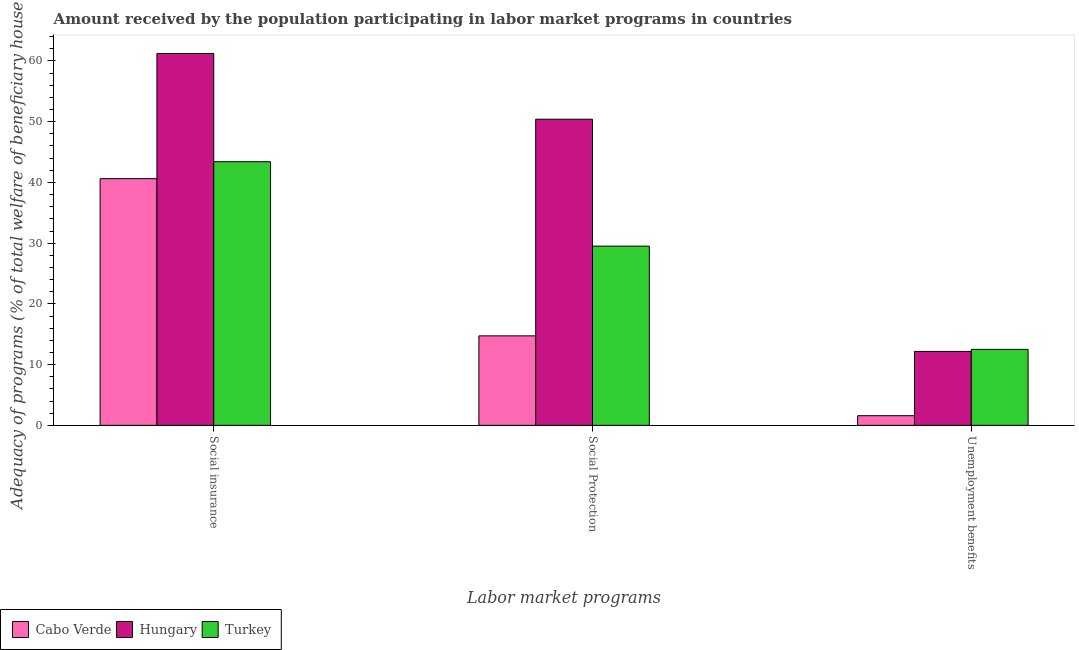Are the number of bars on each tick of the X-axis equal?
Provide a succinct answer. Yes. What is the label of the 2nd group of bars from the left?
Your response must be concise. Social Protection. What is the amount received by the population participating in social protection programs in Turkey?
Your response must be concise. 29.51. Across all countries, what is the maximum amount received by the population participating in unemployment benefits programs?
Your response must be concise. 12.51. Across all countries, what is the minimum amount received by the population participating in unemployment benefits programs?
Ensure brevity in your answer.  1.59. In which country was the amount received by the population participating in social protection programs maximum?
Provide a short and direct response. Hungary. In which country was the amount received by the population participating in unemployment benefits programs minimum?
Offer a very short reply. Cabo Verde. What is the total amount received by the population participating in social insurance programs in the graph?
Make the answer very short. 145.27. What is the difference between the amount received by the population participating in social insurance programs in Turkey and that in Cabo Verde?
Make the answer very short. 2.79. What is the difference between the amount received by the population participating in social protection programs in Hungary and the amount received by the population participating in unemployment benefits programs in Turkey?
Give a very brief answer. 37.9. What is the average amount received by the population participating in social protection programs per country?
Provide a succinct answer. 31.55. What is the difference between the amount received by the population participating in social insurance programs and amount received by the population participating in unemployment benefits programs in Hungary?
Make the answer very short. 49.06. In how many countries, is the amount received by the population participating in social protection programs greater than 36 %?
Provide a succinct answer. 1. What is the ratio of the amount received by the population participating in unemployment benefits programs in Turkey to that in Hungary?
Your response must be concise. 1.03. Is the amount received by the population participating in social insurance programs in Cabo Verde less than that in Turkey?
Your answer should be very brief. Yes. What is the difference between the highest and the second highest amount received by the population participating in unemployment benefits programs?
Provide a succinct answer. 0.34. What is the difference between the highest and the lowest amount received by the population participating in social insurance programs?
Offer a terse response. 20.62. What does the 1st bar from the left in Social Protection represents?
Provide a short and direct response. Cabo Verde. What does the 3rd bar from the right in Social Protection represents?
Ensure brevity in your answer.  Cabo Verde. Is it the case that in every country, the sum of the amount received by the population participating in social insurance programs and amount received by the population participating in social protection programs is greater than the amount received by the population participating in unemployment benefits programs?
Keep it short and to the point. Yes. Are all the bars in the graph horizontal?
Your answer should be compact. No. Does the graph contain grids?
Provide a short and direct response. No. Where does the legend appear in the graph?
Your answer should be very brief. Bottom left. How are the legend labels stacked?
Ensure brevity in your answer.  Horizontal. What is the title of the graph?
Ensure brevity in your answer.  Amount received by the population participating in labor market programs in countries. Does "Benin" appear as one of the legend labels in the graph?
Your response must be concise. No. What is the label or title of the X-axis?
Offer a terse response. Labor market programs. What is the label or title of the Y-axis?
Offer a terse response. Adequacy of programs (% of total welfare of beneficiary households). What is the Adequacy of programs (% of total welfare of beneficiary households) in Cabo Verde in Social insurance?
Your answer should be compact. 40.62. What is the Adequacy of programs (% of total welfare of beneficiary households) of Hungary in Social insurance?
Make the answer very short. 61.24. What is the Adequacy of programs (% of total welfare of beneficiary households) in Turkey in Social insurance?
Provide a short and direct response. 43.41. What is the Adequacy of programs (% of total welfare of beneficiary households) in Cabo Verde in Social Protection?
Keep it short and to the point. 14.74. What is the Adequacy of programs (% of total welfare of beneficiary households) in Hungary in Social Protection?
Your answer should be compact. 50.41. What is the Adequacy of programs (% of total welfare of beneficiary households) in Turkey in Social Protection?
Offer a very short reply. 29.51. What is the Adequacy of programs (% of total welfare of beneficiary households) in Cabo Verde in Unemployment benefits?
Make the answer very short. 1.59. What is the Adequacy of programs (% of total welfare of beneficiary households) in Hungary in Unemployment benefits?
Keep it short and to the point. 12.17. What is the Adequacy of programs (% of total welfare of beneficiary households) in Turkey in Unemployment benefits?
Make the answer very short. 12.51. Across all Labor market programs, what is the maximum Adequacy of programs (% of total welfare of beneficiary households) in Cabo Verde?
Provide a succinct answer. 40.62. Across all Labor market programs, what is the maximum Adequacy of programs (% of total welfare of beneficiary households) in Hungary?
Provide a succinct answer. 61.24. Across all Labor market programs, what is the maximum Adequacy of programs (% of total welfare of beneficiary households) of Turkey?
Your response must be concise. 43.41. Across all Labor market programs, what is the minimum Adequacy of programs (% of total welfare of beneficiary households) of Cabo Verde?
Ensure brevity in your answer.  1.59. Across all Labor market programs, what is the minimum Adequacy of programs (% of total welfare of beneficiary households) in Hungary?
Provide a succinct answer. 12.17. Across all Labor market programs, what is the minimum Adequacy of programs (% of total welfare of beneficiary households) of Turkey?
Your response must be concise. 12.51. What is the total Adequacy of programs (% of total welfare of beneficiary households) of Cabo Verde in the graph?
Your response must be concise. 56.95. What is the total Adequacy of programs (% of total welfare of beneficiary households) in Hungary in the graph?
Your response must be concise. 123.82. What is the total Adequacy of programs (% of total welfare of beneficiary households) in Turkey in the graph?
Provide a succinct answer. 85.43. What is the difference between the Adequacy of programs (% of total welfare of beneficiary households) of Cabo Verde in Social insurance and that in Social Protection?
Offer a terse response. 25.88. What is the difference between the Adequacy of programs (% of total welfare of beneficiary households) in Hungary in Social insurance and that in Social Protection?
Offer a very short reply. 10.83. What is the difference between the Adequacy of programs (% of total welfare of beneficiary households) of Turkey in Social insurance and that in Social Protection?
Your answer should be compact. 13.9. What is the difference between the Adequacy of programs (% of total welfare of beneficiary households) in Cabo Verde in Social insurance and that in Unemployment benefits?
Your response must be concise. 39.03. What is the difference between the Adequacy of programs (% of total welfare of beneficiary households) of Hungary in Social insurance and that in Unemployment benefits?
Offer a very short reply. 49.06. What is the difference between the Adequacy of programs (% of total welfare of beneficiary households) in Turkey in Social insurance and that in Unemployment benefits?
Your answer should be compact. 30.9. What is the difference between the Adequacy of programs (% of total welfare of beneficiary households) in Cabo Verde in Social Protection and that in Unemployment benefits?
Provide a short and direct response. 13.15. What is the difference between the Adequacy of programs (% of total welfare of beneficiary households) in Hungary in Social Protection and that in Unemployment benefits?
Your answer should be very brief. 38.23. What is the difference between the Adequacy of programs (% of total welfare of beneficiary households) of Turkey in Social Protection and that in Unemployment benefits?
Ensure brevity in your answer.  17. What is the difference between the Adequacy of programs (% of total welfare of beneficiary households) of Cabo Verde in Social insurance and the Adequacy of programs (% of total welfare of beneficiary households) of Hungary in Social Protection?
Your answer should be very brief. -9.79. What is the difference between the Adequacy of programs (% of total welfare of beneficiary households) in Cabo Verde in Social insurance and the Adequacy of programs (% of total welfare of beneficiary households) in Turkey in Social Protection?
Give a very brief answer. 11.11. What is the difference between the Adequacy of programs (% of total welfare of beneficiary households) in Hungary in Social insurance and the Adequacy of programs (% of total welfare of beneficiary households) in Turkey in Social Protection?
Offer a very short reply. 31.73. What is the difference between the Adequacy of programs (% of total welfare of beneficiary households) of Cabo Verde in Social insurance and the Adequacy of programs (% of total welfare of beneficiary households) of Hungary in Unemployment benefits?
Give a very brief answer. 28.45. What is the difference between the Adequacy of programs (% of total welfare of beneficiary households) in Cabo Verde in Social insurance and the Adequacy of programs (% of total welfare of beneficiary households) in Turkey in Unemployment benefits?
Keep it short and to the point. 28.11. What is the difference between the Adequacy of programs (% of total welfare of beneficiary households) in Hungary in Social insurance and the Adequacy of programs (% of total welfare of beneficiary households) in Turkey in Unemployment benefits?
Provide a short and direct response. 48.73. What is the difference between the Adequacy of programs (% of total welfare of beneficiary households) of Cabo Verde in Social Protection and the Adequacy of programs (% of total welfare of beneficiary households) of Hungary in Unemployment benefits?
Offer a terse response. 2.56. What is the difference between the Adequacy of programs (% of total welfare of beneficiary households) in Cabo Verde in Social Protection and the Adequacy of programs (% of total welfare of beneficiary households) in Turkey in Unemployment benefits?
Provide a short and direct response. 2.23. What is the difference between the Adequacy of programs (% of total welfare of beneficiary households) of Hungary in Social Protection and the Adequacy of programs (% of total welfare of beneficiary households) of Turkey in Unemployment benefits?
Ensure brevity in your answer.  37.9. What is the average Adequacy of programs (% of total welfare of beneficiary households) of Cabo Verde per Labor market programs?
Keep it short and to the point. 18.98. What is the average Adequacy of programs (% of total welfare of beneficiary households) of Hungary per Labor market programs?
Give a very brief answer. 41.27. What is the average Adequacy of programs (% of total welfare of beneficiary households) in Turkey per Labor market programs?
Offer a terse response. 28.48. What is the difference between the Adequacy of programs (% of total welfare of beneficiary households) in Cabo Verde and Adequacy of programs (% of total welfare of beneficiary households) in Hungary in Social insurance?
Keep it short and to the point. -20.62. What is the difference between the Adequacy of programs (% of total welfare of beneficiary households) in Cabo Verde and Adequacy of programs (% of total welfare of beneficiary households) in Turkey in Social insurance?
Provide a short and direct response. -2.79. What is the difference between the Adequacy of programs (% of total welfare of beneficiary households) of Hungary and Adequacy of programs (% of total welfare of beneficiary households) of Turkey in Social insurance?
Your response must be concise. 17.82. What is the difference between the Adequacy of programs (% of total welfare of beneficiary households) of Cabo Verde and Adequacy of programs (% of total welfare of beneficiary households) of Hungary in Social Protection?
Make the answer very short. -35.67. What is the difference between the Adequacy of programs (% of total welfare of beneficiary households) of Cabo Verde and Adequacy of programs (% of total welfare of beneficiary households) of Turkey in Social Protection?
Offer a terse response. -14.77. What is the difference between the Adequacy of programs (% of total welfare of beneficiary households) of Hungary and Adequacy of programs (% of total welfare of beneficiary households) of Turkey in Social Protection?
Your answer should be compact. 20.9. What is the difference between the Adequacy of programs (% of total welfare of beneficiary households) in Cabo Verde and Adequacy of programs (% of total welfare of beneficiary households) in Hungary in Unemployment benefits?
Provide a succinct answer. -10.59. What is the difference between the Adequacy of programs (% of total welfare of beneficiary households) of Cabo Verde and Adequacy of programs (% of total welfare of beneficiary households) of Turkey in Unemployment benefits?
Your answer should be very brief. -10.92. What is the difference between the Adequacy of programs (% of total welfare of beneficiary households) of Hungary and Adequacy of programs (% of total welfare of beneficiary households) of Turkey in Unemployment benefits?
Your answer should be compact. -0.34. What is the ratio of the Adequacy of programs (% of total welfare of beneficiary households) of Cabo Verde in Social insurance to that in Social Protection?
Provide a short and direct response. 2.76. What is the ratio of the Adequacy of programs (% of total welfare of beneficiary households) in Hungary in Social insurance to that in Social Protection?
Make the answer very short. 1.21. What is the ratio of the Adequacy of programs (% of total welfare of beneficiary households) of Turkey in Social insurance to that in Social Protection?
Provide a short and direct response. 1.47. What is the ratio of the Adequacy of programs (% of total welfare of beneficiary households) of Cabo Verde in Social insurance to that in Unemployment benefits?
Ensure brevity in your answer.  25.56. What is the ratio of the Adequacy of programs (% of total welfare of beneficiary households) in Hungary in Social insurance to that in Unemployment benefits?
Keep it short and to the point. 5.03. What is the ratio of the Adequacy of programs (% of total welfare of beneficiary households) in Turkey in Social insurance to that in Unemployment benefits?
Keep it short and to the point. 3.47. What is the ratio of the Adequacy of programs (% of total welfare of beneficiary households) in Cabo Verde in Social Protection to that in Unemployment benefits?
Give a very brief answer. 9.27. What is the ratio of the Adequacy of programs (% of total welfare of beneficiary households) of Hungary in Social Protection to that in Unemployment benefits?
Make the answer very short. 4.14. What is the ratio of the Adequacy of programs (% of total welfare of beneficiary households) in Turkey in Social Protection to that in Unemployment benefits?
Make the answer very short. 2.36. What is the difference between the highest and the second highest Adequacy of programs (% of total welfare of beneficiary households) in Cabo Verde?
Provide a short and direct response. 25.88. What is the difference between the highest and the second highest Adequacy of programs (% of total welfare of beneficiary households) in Hungary?
Your answer should be very brief. 10.83. What is the difference between the highest and the second highest Adequacy of programs (% of total welfare of beneficiary households) in Turkey?
Provide a short and direct response. 13.9. What is the difference between the highest and the lowest Adequacy of programs (% of total welfare of beneficiary households) in Cabo Verde?
Your answer should be very brief. 39.03. What is the difference between the highest and the lowest Adequacy of programs (% of total welfare of beneficiary households) of Hungary?
Your answer should be very brief. 49.06. What is the difference between the highest and the lowest Adequacy of programs (% of total welfare of beneficiary households) in Turkey?
Your answer should be compact. 30.9. 